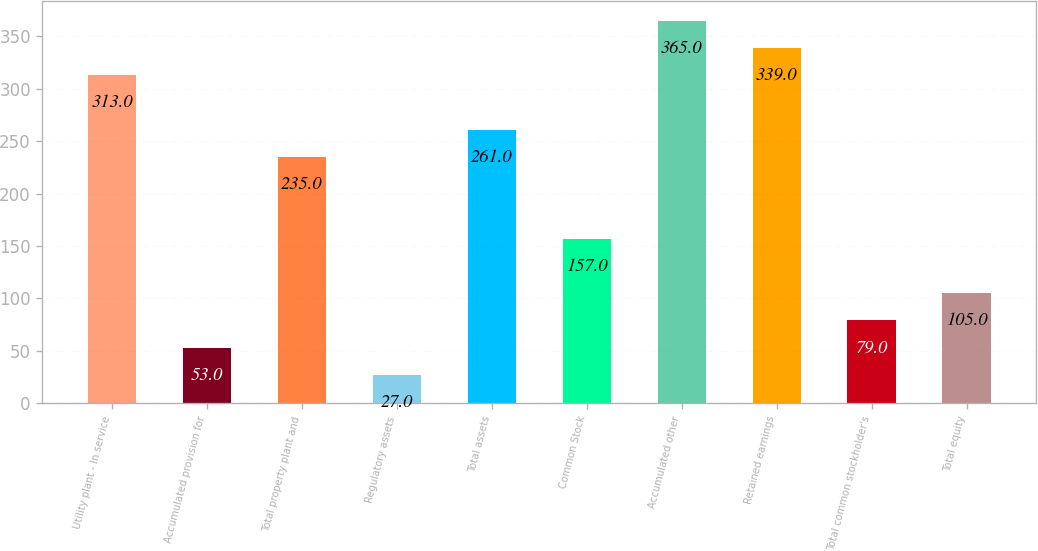<chart> <loc_0><loc_0><loc_500><loc_500><bar_chart><fcel>Utility plant - In service<fcel>Accumulated provision for<fcel>Total property plant and<fcel>Regulatory assets<fcel>Total assets<fcel>Common Stock<fcel>Accumulated other<fcel>Retained earnings<fcel>Total common stockholder's<fcel>Total equity<nl><fcel>313<fcel>53<fcel>235<fcel>27<fcel>261<fcel>157<fcel>365<fcel>339<fcel>79<fcel>105<nl></chart> 